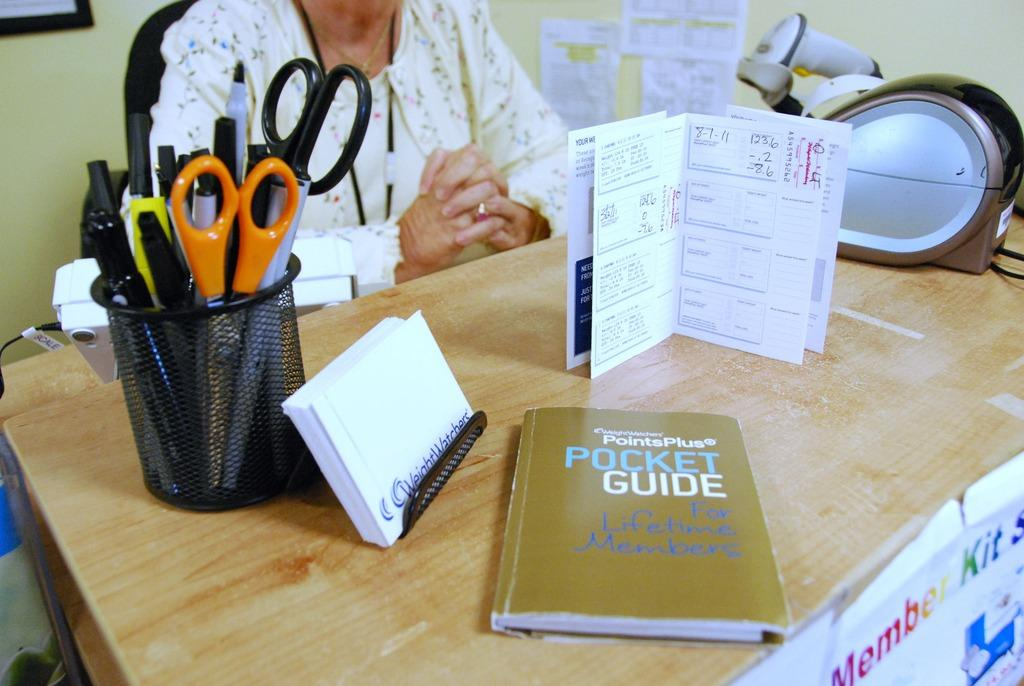<image>
Describe the image concisely. A person sitting at a desk that has a book on the desk titled Pocket Guide for Lifetime Members. 